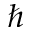Convert formula to latex. <formula><loc_0><loc_0><loc_500><loc_500>\hbar</formula> 